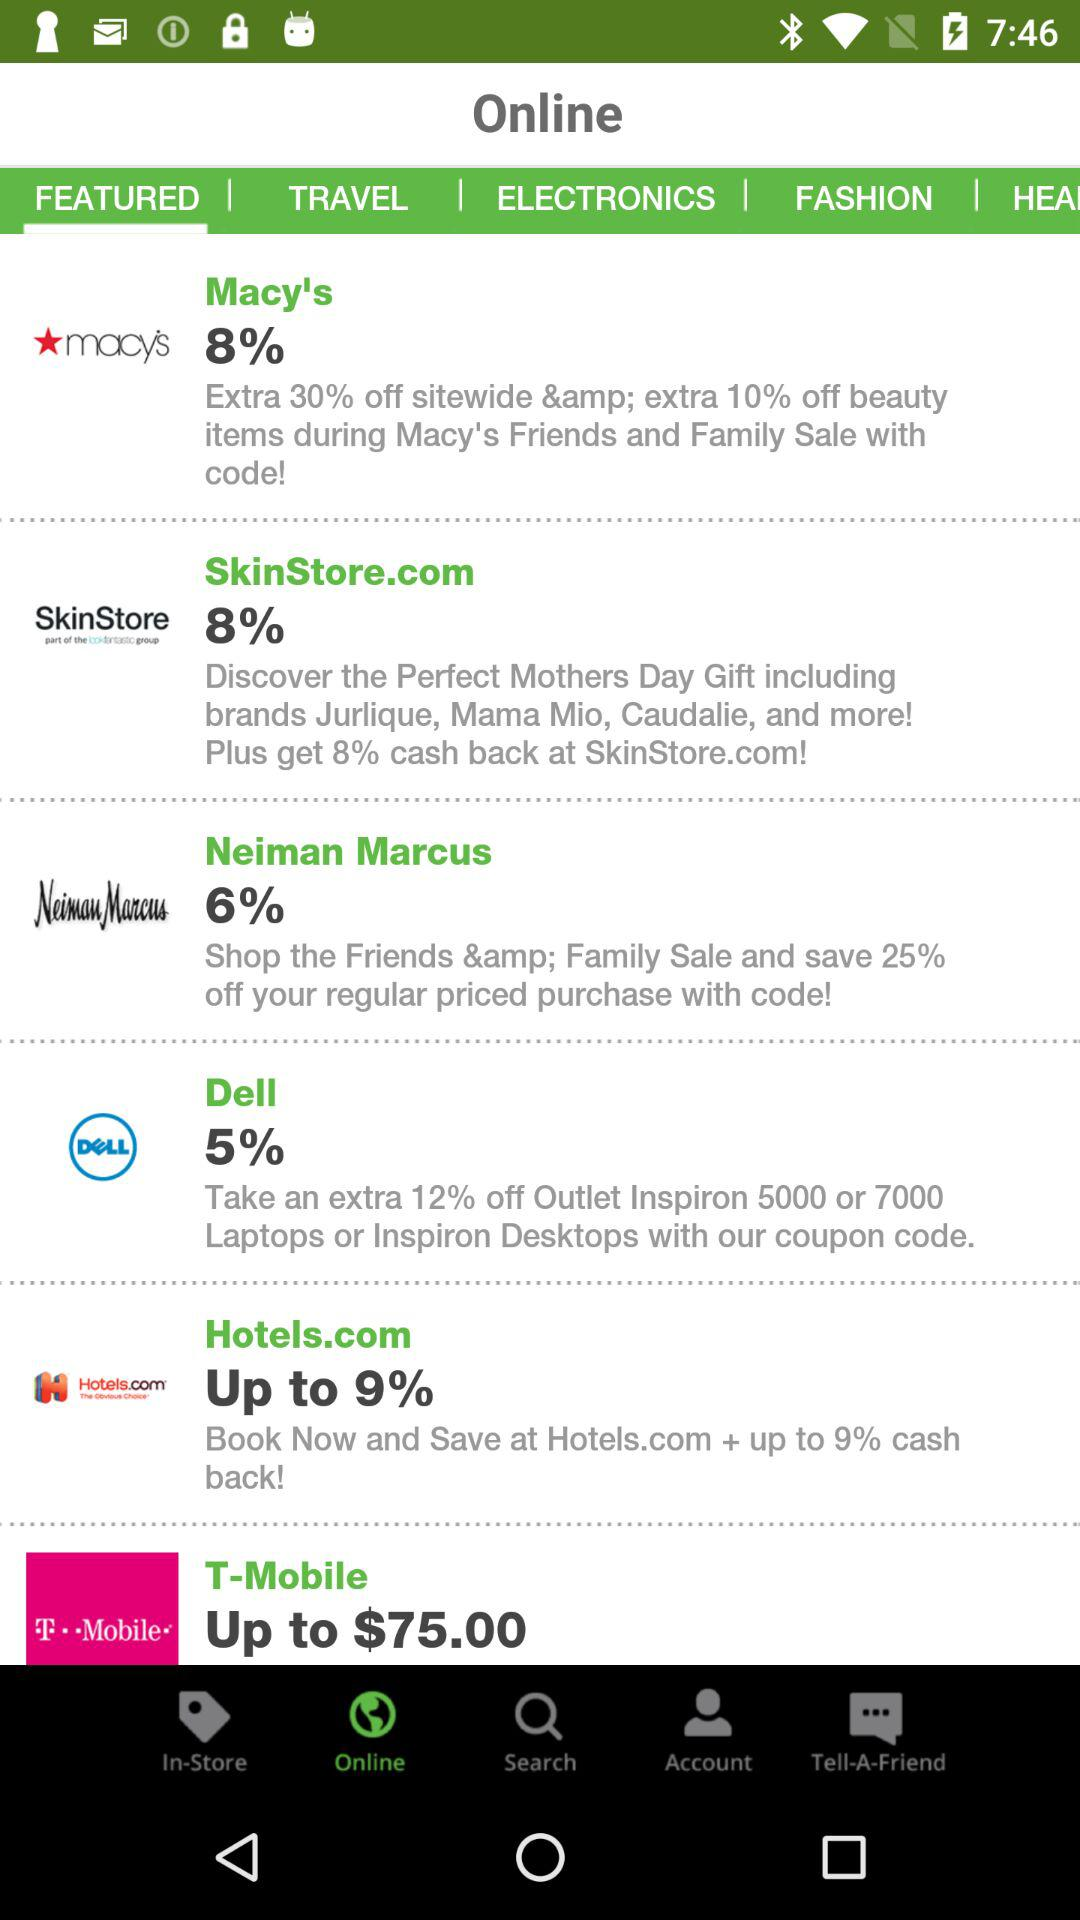How much is the discount for "Dell"? There is a 5% discount and an extra 12% discount for "Dell". 